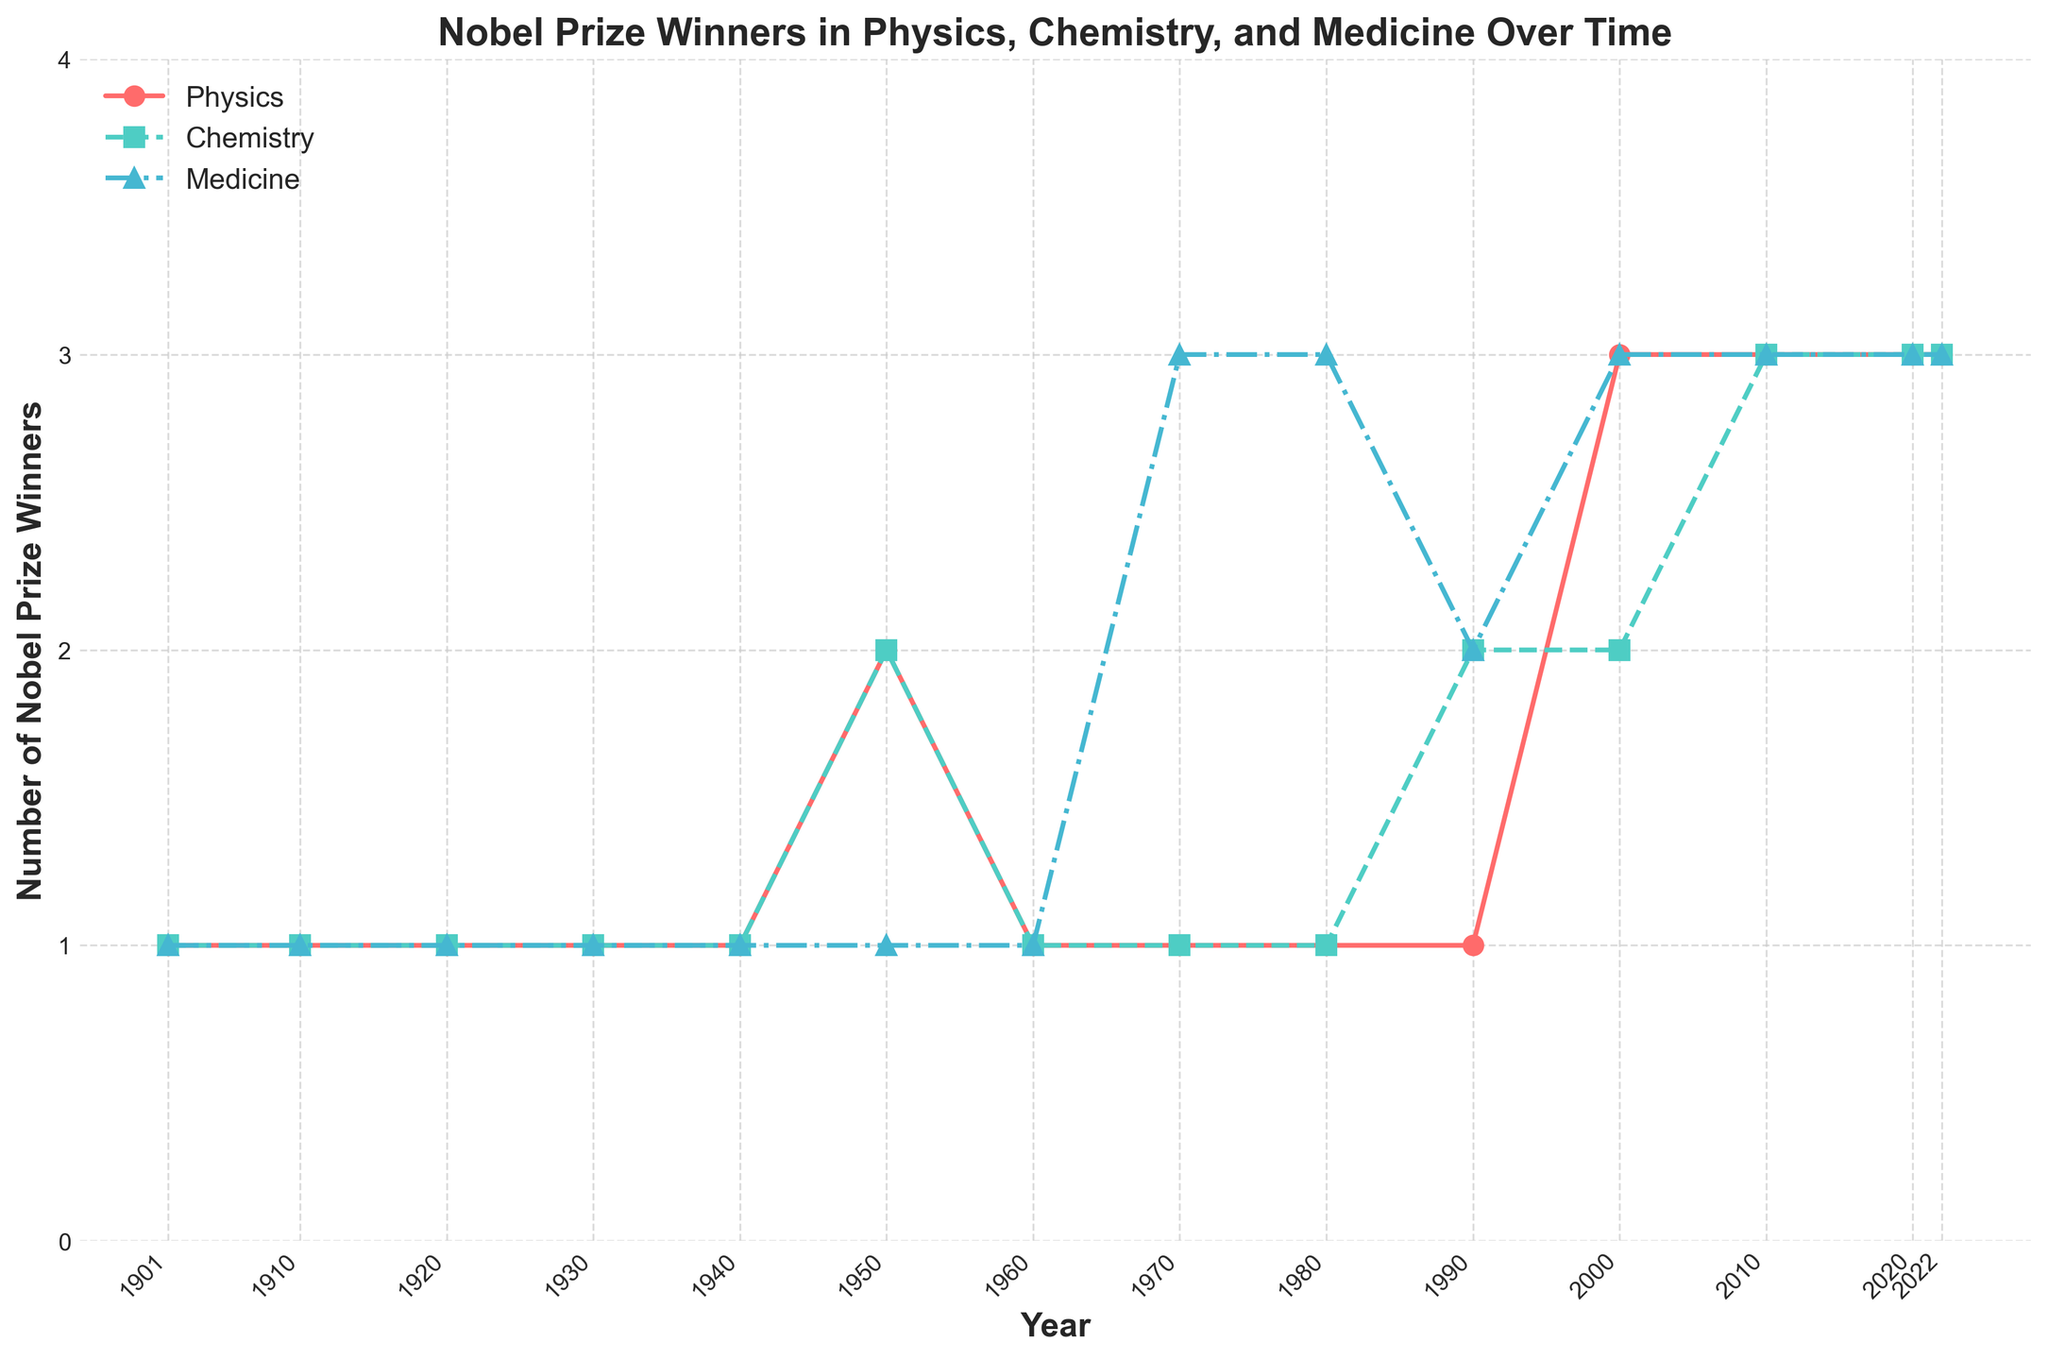Which year had the highest number of Nobel Prize winners in Physics? By examining the line representing Physics (red line), the highest number of Nobel Prize winners is reached at the year 2000, 2010, 2020, and 2022 with three winners each year.
Answer: 2000, 2010, 2020, 2022 Which field had the most Nobel Prize winners in the year 1970? Check the values for Physics (red line), Chemistry (green line), and Medicine (blue line) for the year 1970. Medicine had three winners, while Physics and Chemistry had only one each.
Answer: Medicine How did the number of Nobel Prize winners in Chemistry change from 1990 to 2010? Observe the green line (Chemistry) at 1990 and 2010. It rises from two winners in 1990 to three winners in 2010.
Answer: Increased from 2 to 3 Between 2000 and 2020, which field had the most consistent number of Nobel Prize winners? Inspect the lines for each field from 2000 to 2020. The Medicine (blue line) and Chemistry (green line) have consistent three winners, while Physics (red line) varies slightly.
Answer: Medicine and Chemistry Compare the total number of Nobel Prize winners in Physics and Chemistry for the years 2010 and 2020. Which field had more winners in total? Sum the winners for Physics (3 each in 2010 and 2020) and Chemistry (3 each in 2010 and 2020). Both fields had 6 winners in total.
Answer: Equal (6 each) What is the trend in the number of Nobel Prize winners in Medicine from 1970 to 2022? Look at the blue line (Medicine) between these years. The number of winners increases from three in 1970, to fluctuating with two or three winners and remaining at three after 2000.
Answer: Increasing trend How did the number of Nobel Prize winners in Physics compare to Chemistry in the year 2000? In 2000, Physics (red line) had three winners, while Chemistry (green line) had two winners.
Answer: Physics had more winners (3 vs. 2) What visual attribute differentiates the line representing Medicine from the others? The Medicine line is depicted in blue and uses a triangle marker with a dash-dot line style.
Answer: Blue color with triangle markers and dash-dot line style 